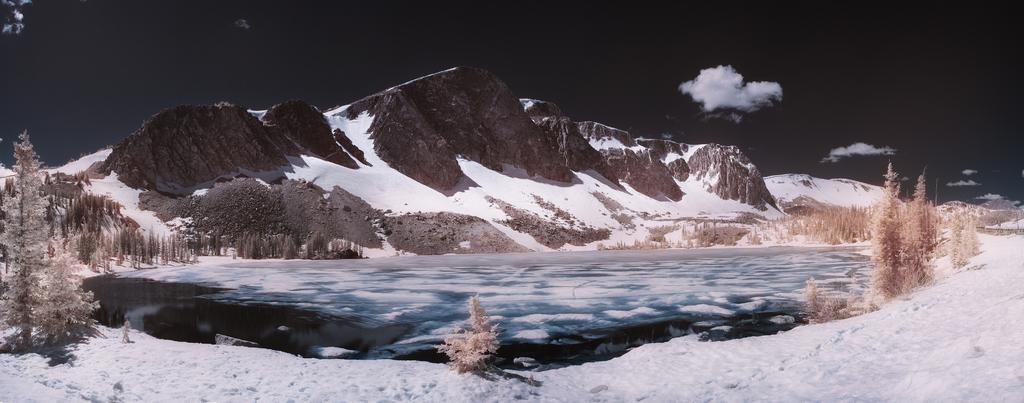In one or two sentences, can you explain what this image depicts? In this image we can see some trees which are covered with the snow and there is a lake and we can see snow on the ground and we can see the mountains in the background and at the top we can see the sky. 